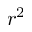Convert formula to latex. <formula><loc_0><loc_0><loc_500><loc_500>r ^ { 2 }</formula> 